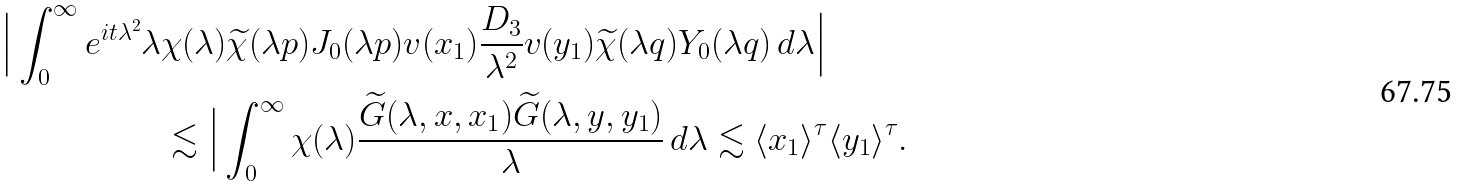Convert formula to latex. <formula><loc_0><loc_0><loc_500><loc_500>\Big | \int _ { 0 } ^ { \infty } e ^ { i t \lambda ^ { 2 } } \lambda & \chi ( \lambda ) \widetilde { \chi } ( \lambda p ) J _ { 0 } ( \lambda p ) v ( x _ { 1 } ) \frac { D _ { 3 } } { \lambda ^ { 2 } } v ( y _ { 1 } ) \widetilde { \chi } ( \lambda q ) Y _ { 0 } ( \lambda q ) \, d \lambda \Big | \\ & \lesssim \Big | \int _ { 0 } ^ { \infty } \chi ( \lambda ) \frac { \widetilde { G } ( \lambda , x , x _ { 1 } ) \widetilde { G } ( \lambda , y , y _ { 1 } ) } { \lambda } \, d \lambda \lesssim \langle x _ { 1 } \rangle ^ { \tau } \langle y _ { 1 } \rangle ^ { \tau } .</formula> 